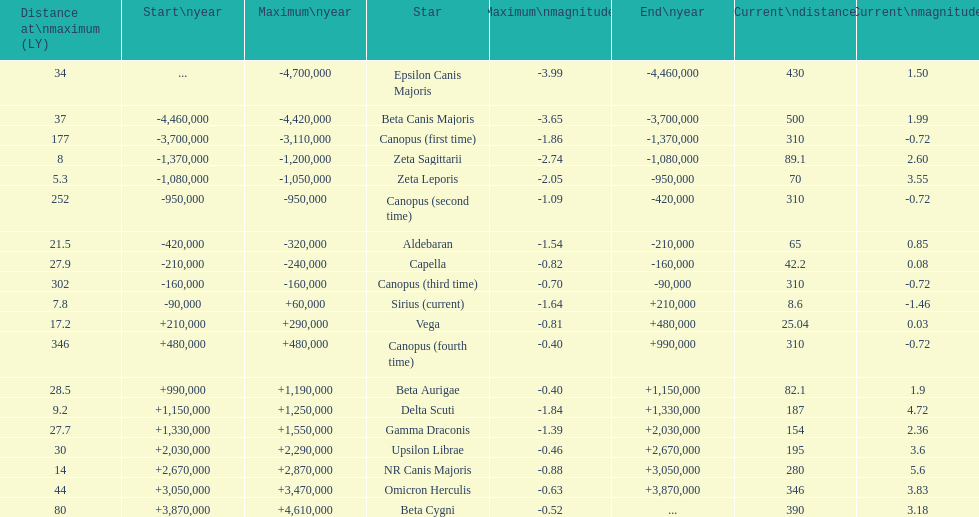How many stars have a magnitude greater than zero? 14. 